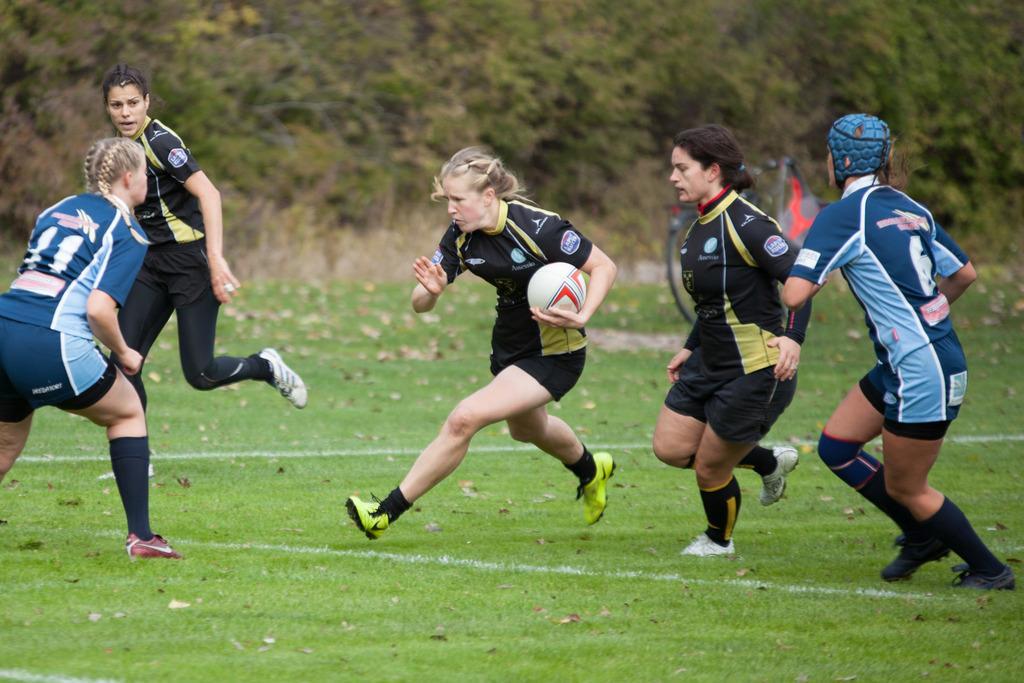In one or two sentences, can you explain what this image depicts? In this picture these five persons are running. This person holding ball. This person wear helmet. This is grass. On the background we can see trees. 